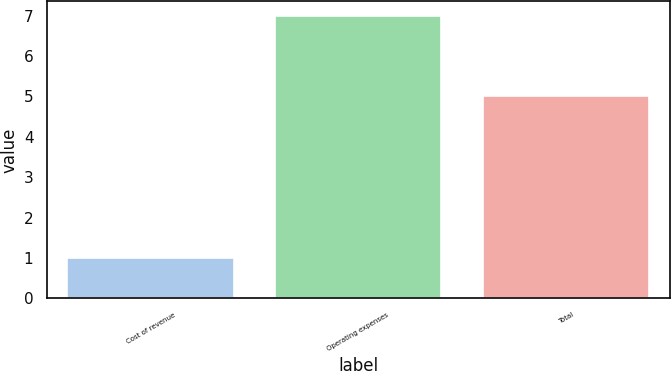Convert chart. <chart><loc_0><loc_0><loc_500><loc_500><bar_chart><fcel>Cost of revenue<fcel>Operating expenses<fcel>Total<nl><fcel>1<fcel>7<fcel>5<nl></chart> 